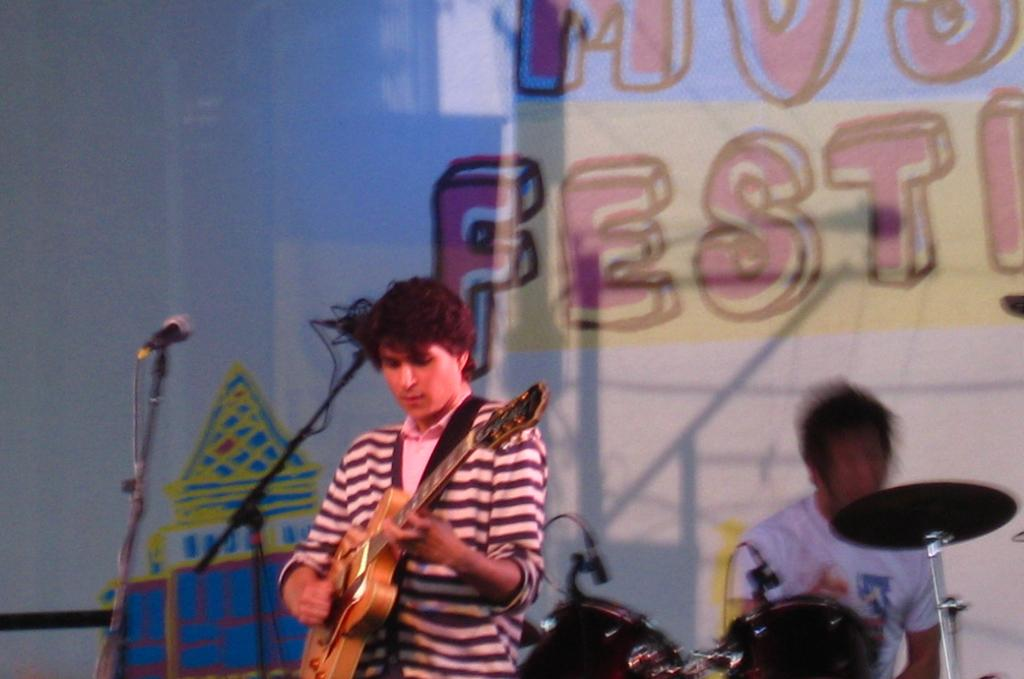What are the two men in the image doing? There is a man playing a guitar and another man playing a drum in the image. What object is on the left side of the image? There is a microphone on the left side of the image. What can be seen in the background of the image? There is a banner in the background of the image. What type of paint is being used to decorate the transport in the image? There is no transport or paint present in the image; it features two men playing musical instruments and a microphone on the left side, and a banner in the background. 